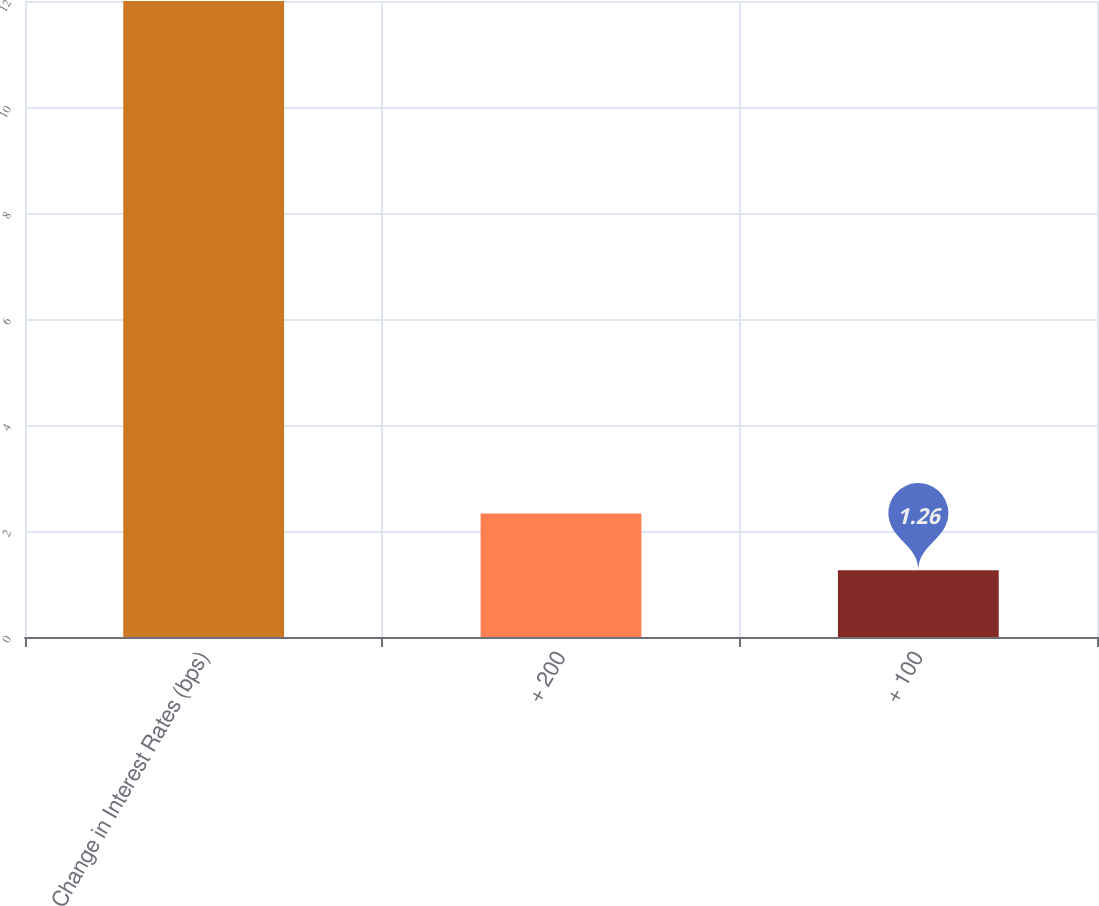Convert chart to OTSL. <chart><loc_0><loc_0><loc_500><loc_500><bar_chart><fcel>Change in Interest Rates (bps)<fcel>+ 200<fcel>+ 100<nl><fcel>12<fcel>2.33<fcel>1.26<nl></chart> 